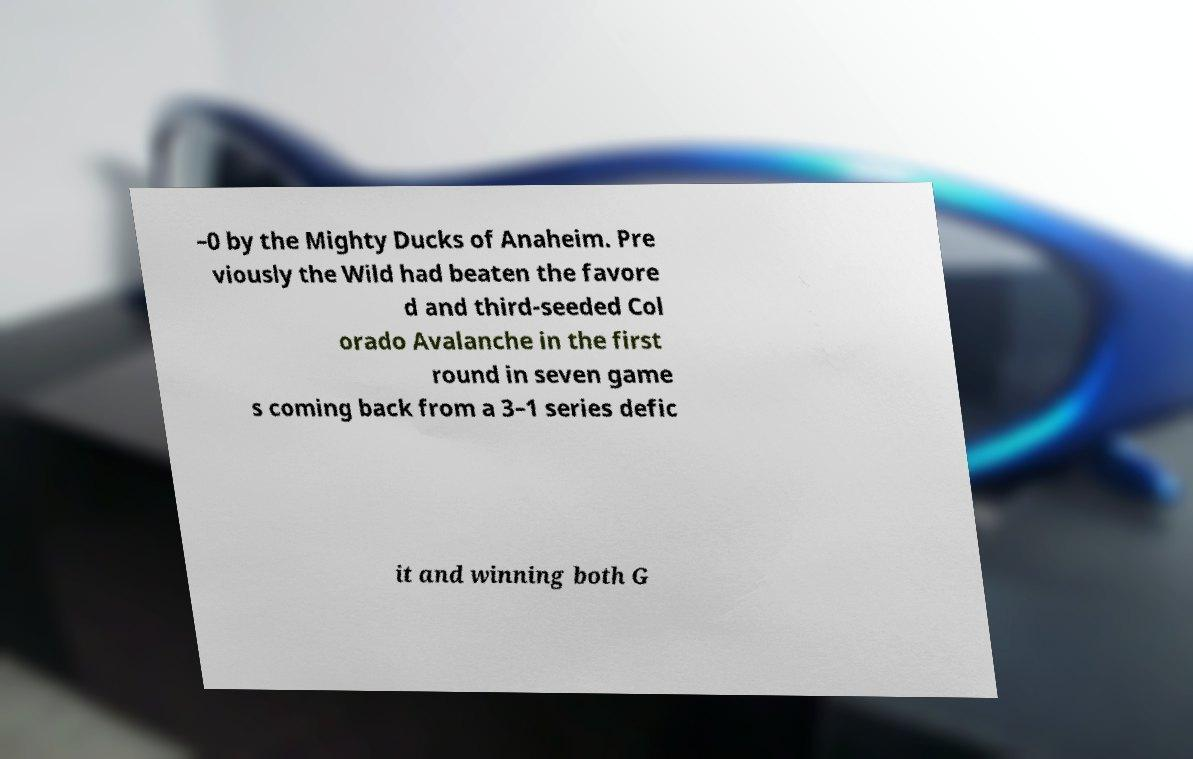What messages or text are displayed in this image? I need them in a readable, typed format. –0 by the Mighty Ducks of Anaheim. Pre viously the Wild had beaten the favore d and third-seeded Col orado Avalanche in the first round in seven game s coming back from a 3–1 series defic it and winning both G 